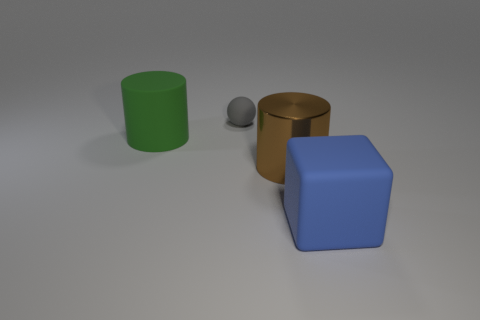What color is the matte cylinder that is the same size as the metal cylinder?
Your response must be concise. Green. Is there another object of the same shape as the big blue matte object?
Offer a terse response. No. The small gray thing that is behind the cylinder that is in front of the cylinder on the left side of the rubber ball is made of what material?
Offer a terse response. Rubber. How many other things are there of the same size as the rubber sphere?
Keep it short and to the point. 0. What color is the matte ball?
Give a very brief answer. Gray. How many rubber objects are purple spheres or brown things?
Keep it short and to the point. 0. Are there any other things that are made of the same material as the blue thing?
Give a very brief answer. Yes. What is the size of the blue matte thing on the right side of the matte thing that is behind the large matte object that is behind the big blue block?
Provide a succinct answer. Large. How big is the rubber thing that is to the right of the large green matte object and behind the large cube?
Keep it short and to the point. Small. What number of blue matte blocks are left of the large green matte thing?
Make the answer very short. 0. 